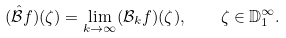<formula> <loc_0><loc_0><loc_500><loc_500>( \hat { \mathcal { B } } f ) ( \zeta ) = \lim _ { k \rightarrow \infty } ( \mathcal { B } _ { k } f ) ( \zeta ) , \quad \zeta \in \mathbb { D } _ { 1 } ^ { \infty } .</formula> 